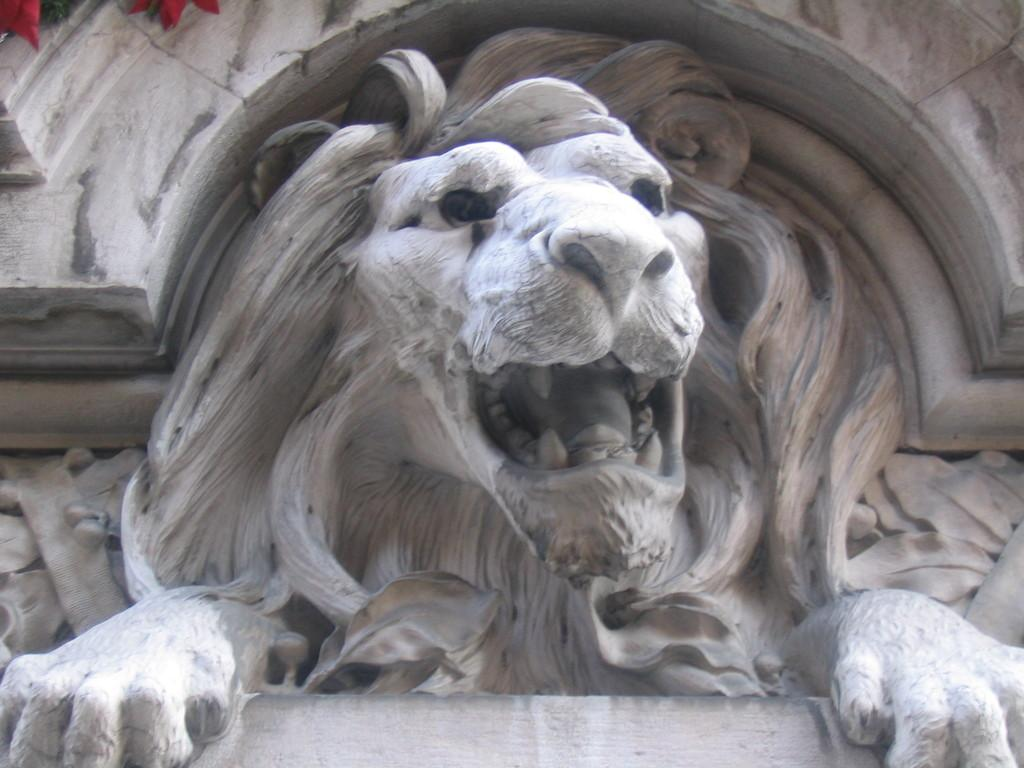What is the main subject of the picture? The main subject of the picture is a sculpture. What type of animal is depicted in the sculpture? The sculpture is of a lion. Where is the lion sculpture located? The lion sculpture is on the wall. What type of spark can be seen coming from the lion's mouth in the image? There is no spark coming from the lion's mouth in the image; it is a sculpture of a lion. How does the lion show respect to the viewer in the image? The lion sculpture does not show respect to the viewer, as it is an inanimate object and cannot display emotions or actions. 